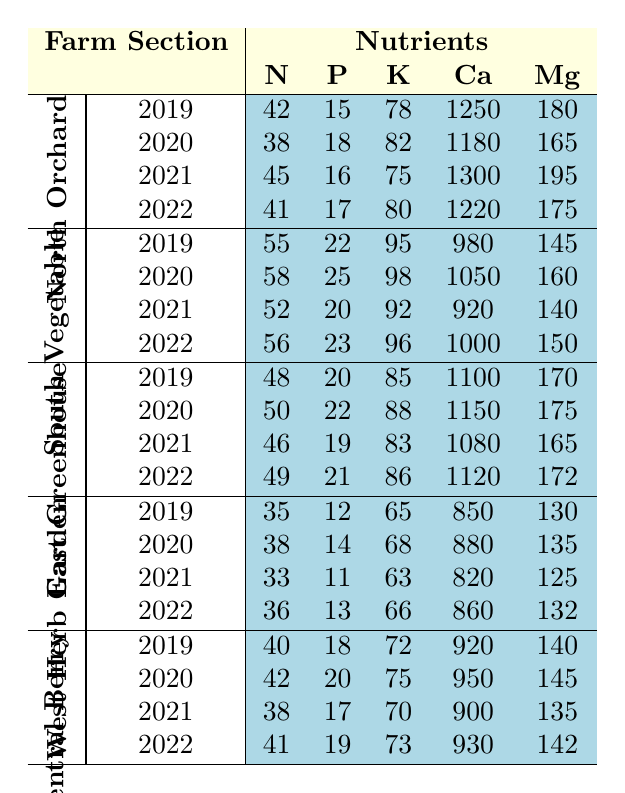What is the nitrogen level in the South Vegetable Field in 2020? According to the table, the nitrogen level in the South Vegetable Field for the year 2020 is directly listed as 58.
Answer: 58 Which farm section had the highest potassium level in 2021? By comparing the potassium levels in all the sections for 2021, the South Vegetable Field had the highest value of 92.
Answer: South Vegetable Field What is the average calcium level in the Central Berry Patch between 2019 and 2022? The calcium levels for Central Berry Patch from 2019 to 2022 are 920, 950, 900, and 930 respectively. The total is 920 + 950 + 900 + 930 = 3700. Dividing this by 4 gives an average of 3700 / 4 = 925.
Answer: 925 Was the magnesium level in the East Greenhouse higher in 2022 than in 2019? The magnesium level in the East Greenhouse in 2019 is 170, and in 2022 it is 172. Since 172 > 170, the statement is true.
Answer: Yes What is the difference in nitrogen levels between the West Herb Garden in 2019 and 2022? The nitrogen level in the West Herb Garden for 2019 is 35 and for 2022 it is 36. The difference is calculated as 36 - 35 = 1.
Answer: 1 Which section had the lowest phosphorus level in 2020? Looking at the phosphorus levels for all sections in 2020: North Orchard (18), South Vegetable Field (25), East Greenhouse (22), West Herb Garden (14), and Central Berry Patch (20). The lowest is West Herb Garden with a phosphorus level of 14.
Answer: West Herb Garden What was the trend for potassium levels from 2019 to 2022 in the North Orchard? The potassium levels in the North Orchard are as follows: 2019 (78), 2020 (82), 2021 (75), 2022 (80). The trend shows an increase from 2019 to 2020, a decrease in 2021, and then an increase in 2022.
Answer: Mixed trend Calculate the average nitrogen level across all farm sections for the year 2021. The nitrogen levels for all sections in 2021 are: North Orchard (45), South Vegetable Field (52), East Greenhouse (46), West Herb Garden (33), and Central Berry Patch (38). The total is 45 + 52 + 46 + 33 + 38 = 214. Thus, the average is 214 / 5 = 42.8.
Answer: 42.8 In which year did the Central Berry Patch have the lowest magnesium level? The magnesium levels for Central Berry Patch across the years are: 2019 (140), 2020 (145), 2021 (135), and 2022 (142). The lowest level is in 2021 at 135.
Answer: 2021 Was the nitrogen level in the North Orchard consistently above 40 from 2019 to 2022? The nitrogen levels in the North Orchard are: 2019 (42), 2020 (38), 2021 (45), and 2022 (41). Since 2020 has a value of 38, it is not consistently above 40.
Answer: No 